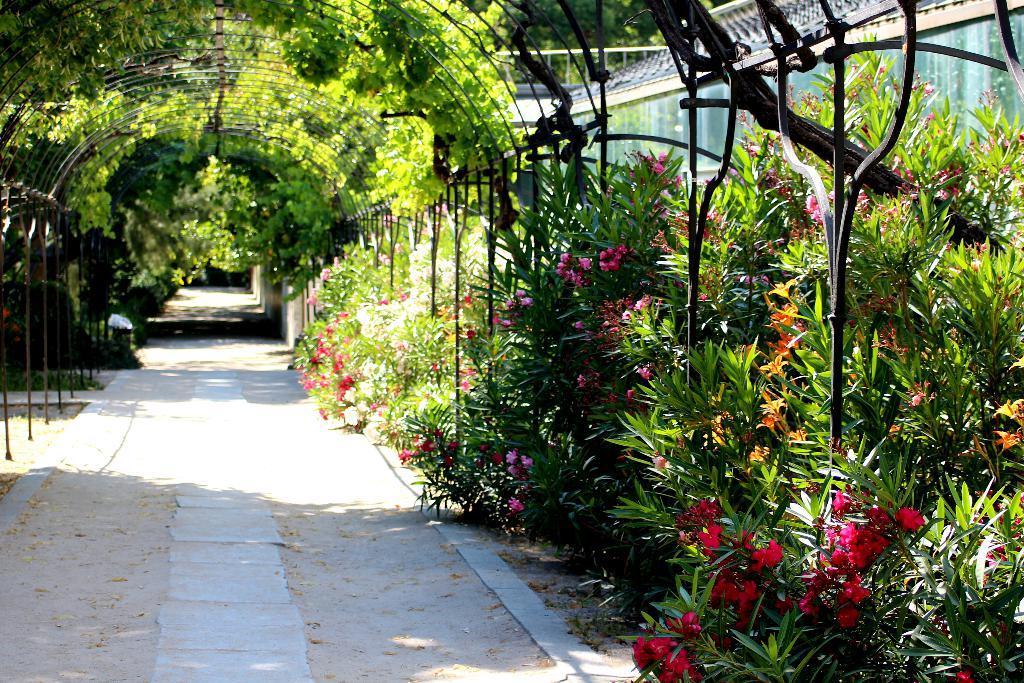Can you describe this image briefly? This image consists of many plants and trees. At the bottom, there is a road. To the right, there is a house. 